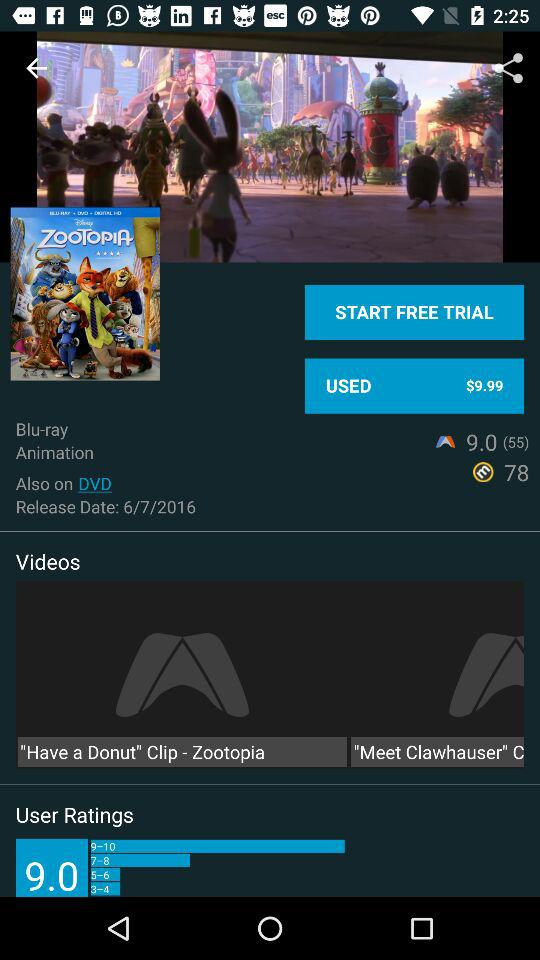How many different types of media are available for this movie?
Answer the question using a single word or phrase. 2 